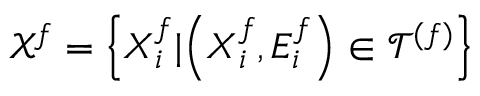<formula> <loc_0><loc_0><loc_500><loc_500>\mathcal { X } ^ { f } = \left \{ X _ { i } ^ { f } | \left ( X _ { i } ^ { f } , E _ { i } ^ { f } \right ) \in \mathcal { T } ^ { ( f ) } \right \}</formula> 